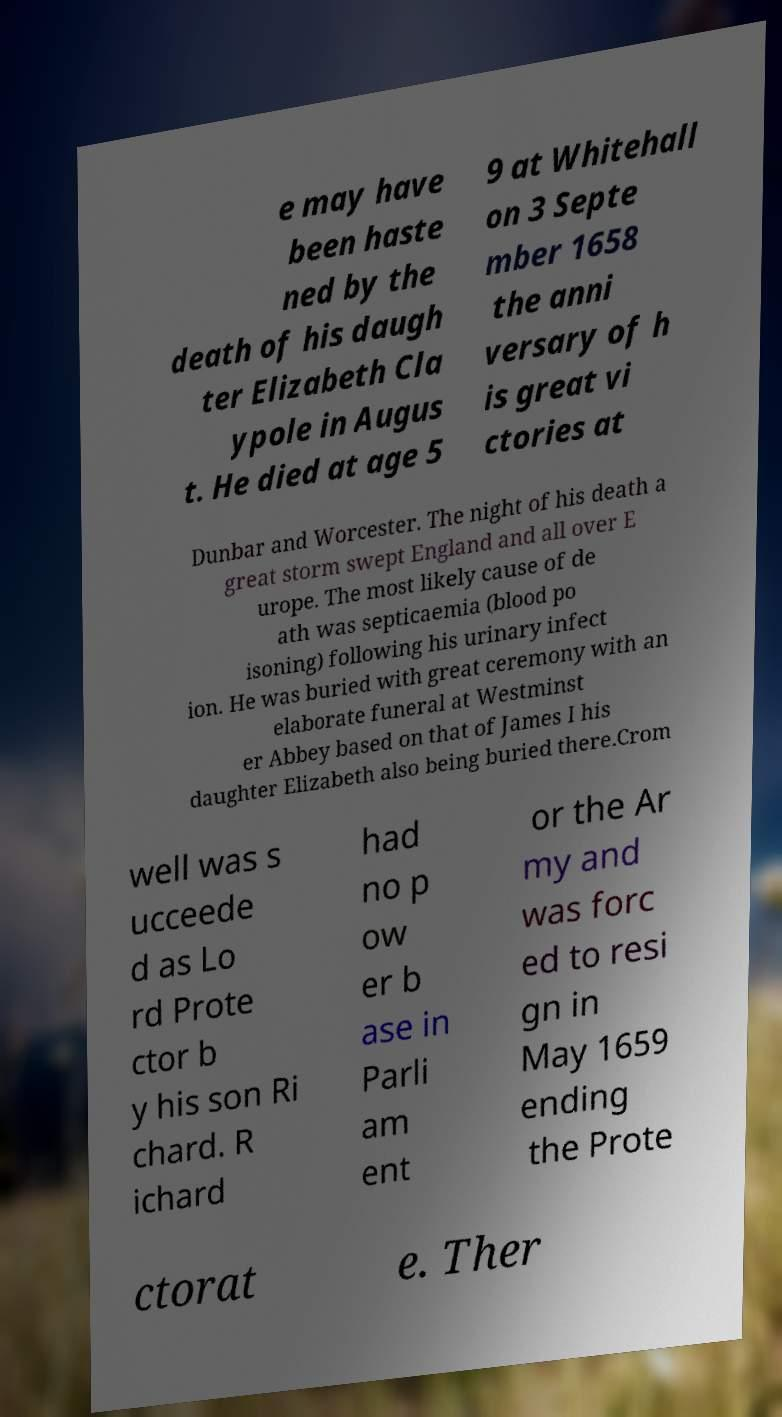Please read and relay the text visible in this image. What does it say? e may have been haste ned by the death of his daugh ter Elizabeth Cla ypole in Augus t. He died at age 5 9 at Whitehall on 3 Septe mber 1658 the anni versary of h is great vi ctories at Dunbar and Worcester. The night of his death a great storm swept England and all over E urope. The most likely cause of de ath was septicaemia (blood po isoning) following his urinary infect ion. He was buried with great ceremony with an elaborate funeral at Westminst er Abbey based on that of James I his daughter Elizabeth also being buried there.Crom well was s ucceede d as Lo rd Prote ctor b y his son Ri chard. R ichard had no p ow er b ase in Parli am ent or the Ar my and was forc ed to resi gn in May 1659 ending the Prote ctorat e. Ther 